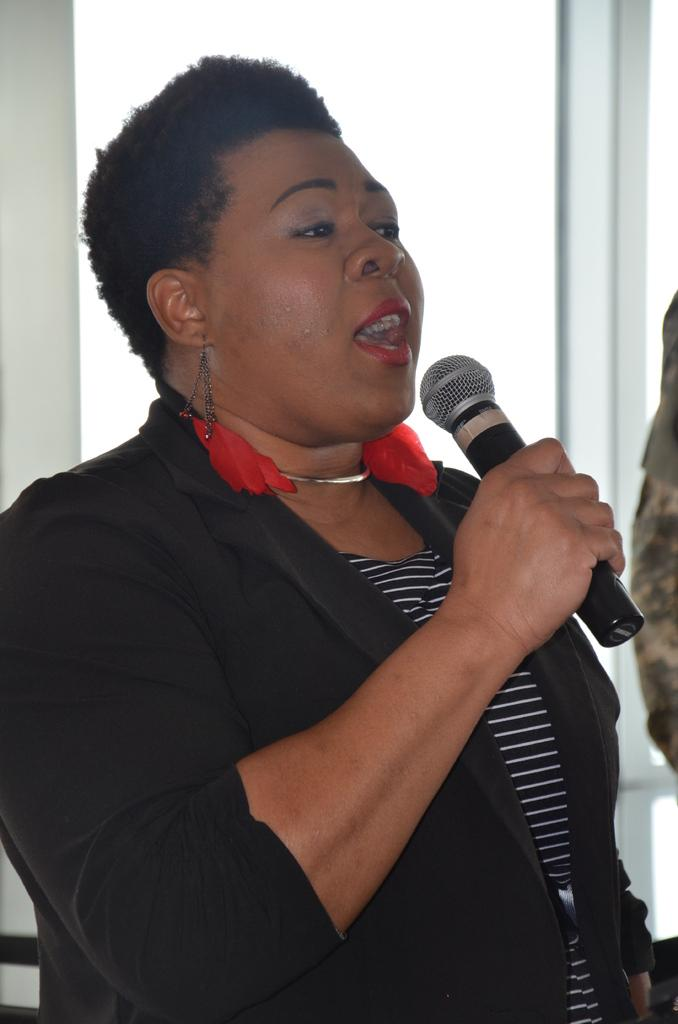Who is the main subject in the image? There is a woman in the image. What is the woman holding in the image? The woman is holding a microphone. What is the woman doing in the image? The woman is speaking, as indicated by her open mouth. What can be seen in the background of the image? There is a glass visible in the background of the image. What type of straw is the woman using to speak into the microphone? There is no straw present in the image; the woman is holding a microphone. 